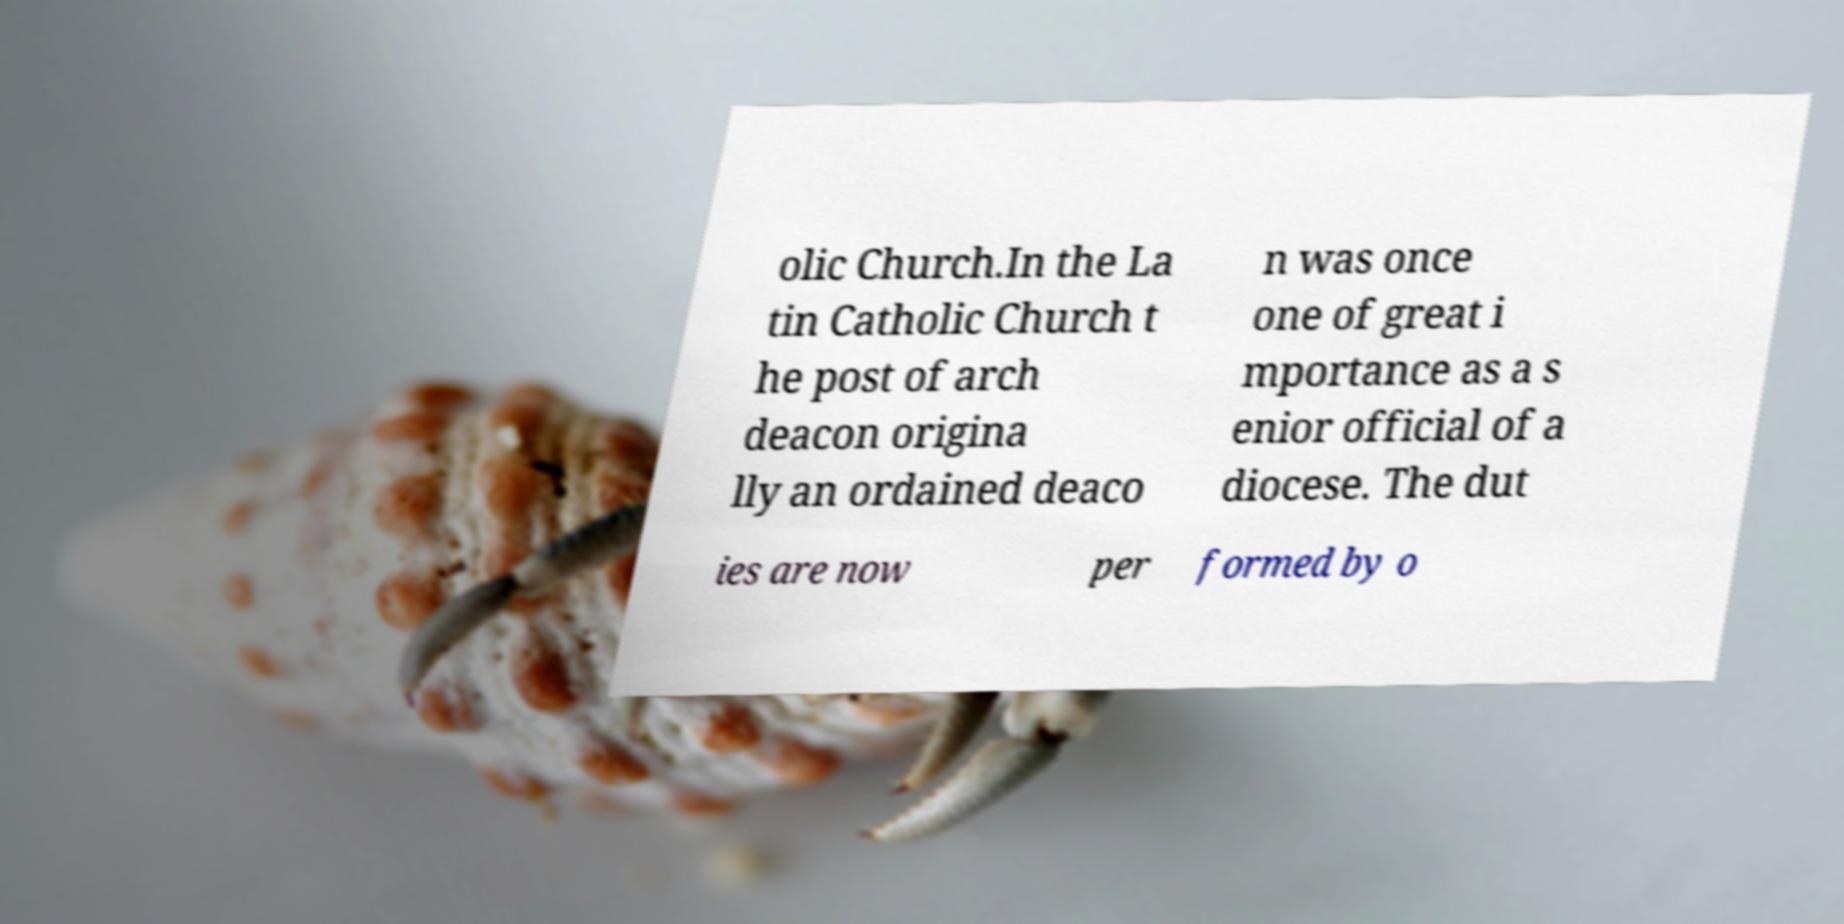Can you read and provide the text displayed in the image?This photo seems to have some interesting text. Can you extract and type it out for me? olic Church.In the La tin Catholic Church t he post of arch deacon origina lly an ordained deaco n was once one of great i mportance as a s enior official of a diocese. The dut ies are now per formed by o 